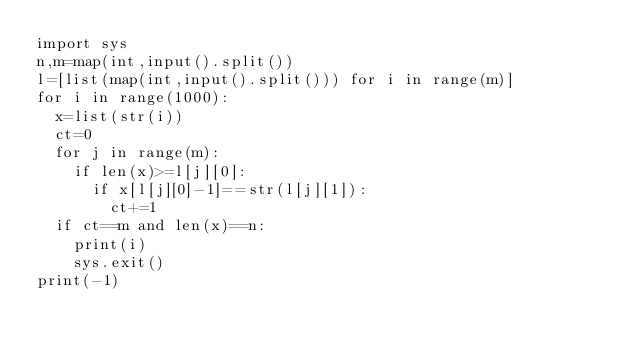Convert code to text. <code><loc_0><loc_0><loc_500><loc_500><_Python_>import sys
n,m=map(int,input().split())
l=[list(map(int,input().split())) for i in range(m)]
for i in range(1000):
  x=list(str(i))
  ct=0
  for j in range(m):
    if len(x)>=l[j][0]:
      if x[l[j][0]-1]==str(l[j][1]):
        ct+=1
  if ct==m and len(x)==n:
    print(i)
    sys.exit()
print(-1)</code> 